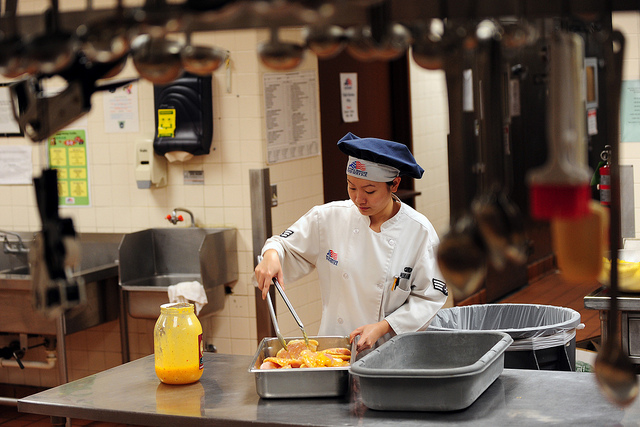What ingredients do you think the chef is working with? From the image, it looks like the chef is preparing a dish with citrus fruits, possibly oranges or grapefruits. The large bottle of orange liquid might contain juice or a marinade. Therefore, the ingredients may include fresh citrus fruits and a corresponding liquid component, adding a vibrant flavor profile to the dish. Do you think the chef needs any additional equipment for the preparation? It's plausible that the chef will benefit from having a cutting board and sharp knife nearby to prepare the citrus fruits more efficiently. Furthermore, having a blender or juicer could help if the chef needs to make fresh juice. Additional bowls for mixing ingredients and a whisk for blending liquids might also be useful. 